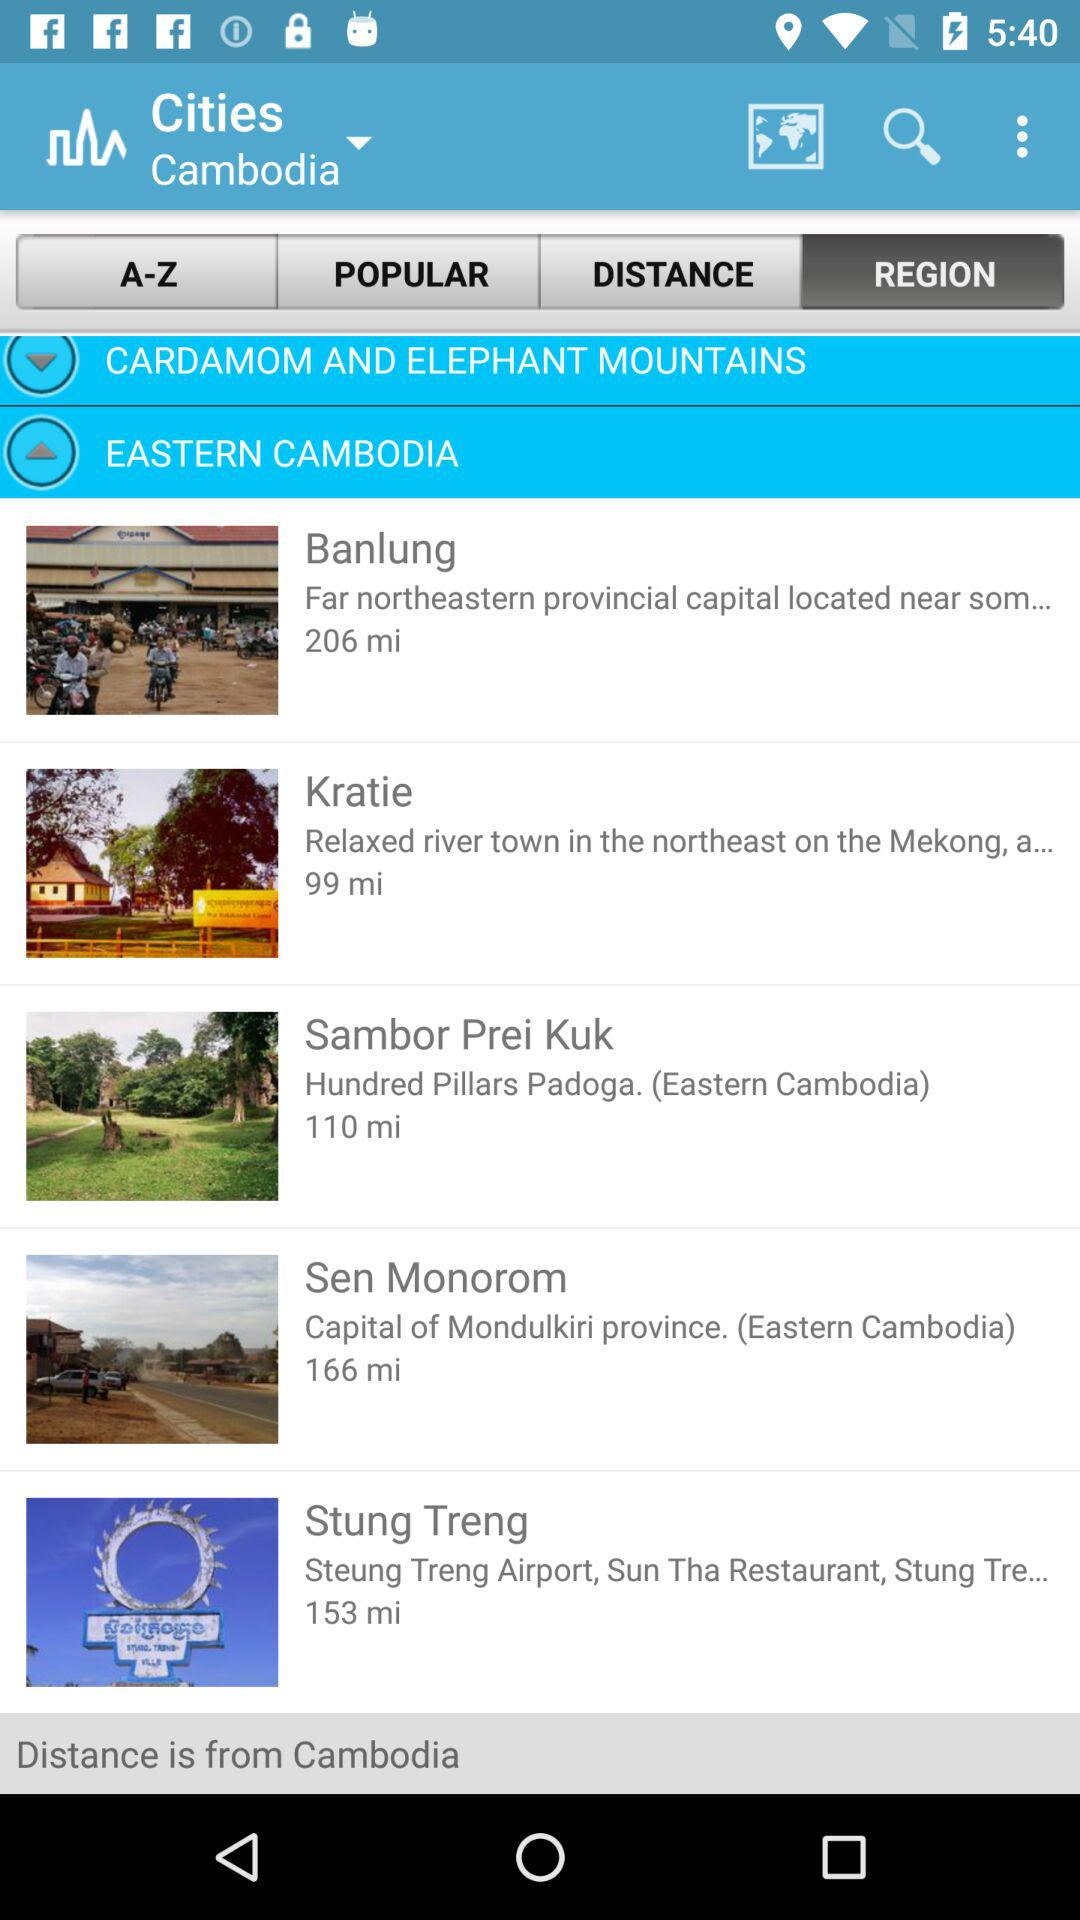What is the selected option? The selected option is "REGION". 